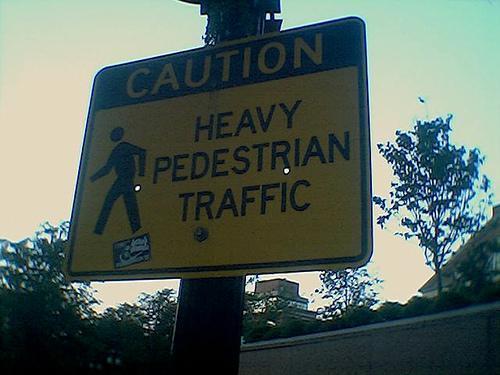How many people are visible?
Give a very brief answer. 1. 